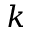Convert formula to latex. <formula><loc_0><loc_0><loc_500><loc_500>k</formula> 